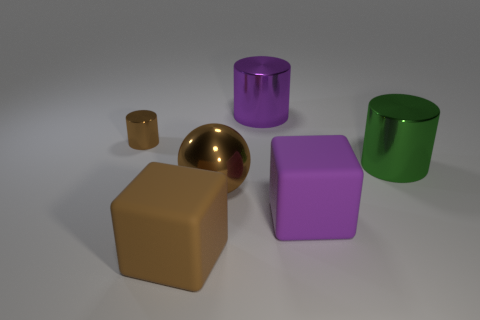Subtract all big cylinders. How many cylinders are left? 1 Add 1 tiny red shiny cubes. How many objects exist? 7 Subtract all brown cubes. How many cubes are left? 1 Subtract all blocks. How many objects are left? 4 Subtract 1 cylinders. How many cylinders are left? 2 Add 4 tiny blue matte things. How many tiny blue matte things exist? 4 Subtract 0 cyan cubes. How many objects are left? 6 Subtract all blue balls. Subtract all yellow cubes. How many balls are left? 1 Subtract all big brown balls. Subtract all brown cubes. How many objects are left? 4 Add 4 brown balls. How many brown balls are left? 5 